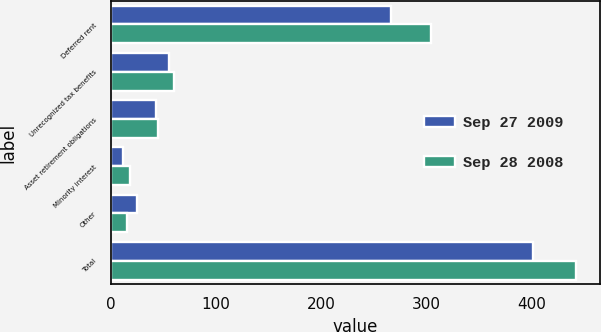Convert chart. <chart><loc_0><loc_0><loc_500><loc_500><stacked_bar_chart><ecel><fcel>Deferred rent<fcel>Unrecognized tax benefits<fcel>Asset retirement obligations<fcel>Minority interest<fcel>Other<fcel>Total<nl><fcel>Sep 27 2009<fcel>266<fcel>55.1<fcel>43.4<fcel>11.2<fcel>25.1<fcel>400.8<nl><fcel>Sep 28 2008<fcel>303.9<fcel>60.4<fcel>44.6<fcel>18.3<fcel>15.2<fcel>442.4<nl></chart> 